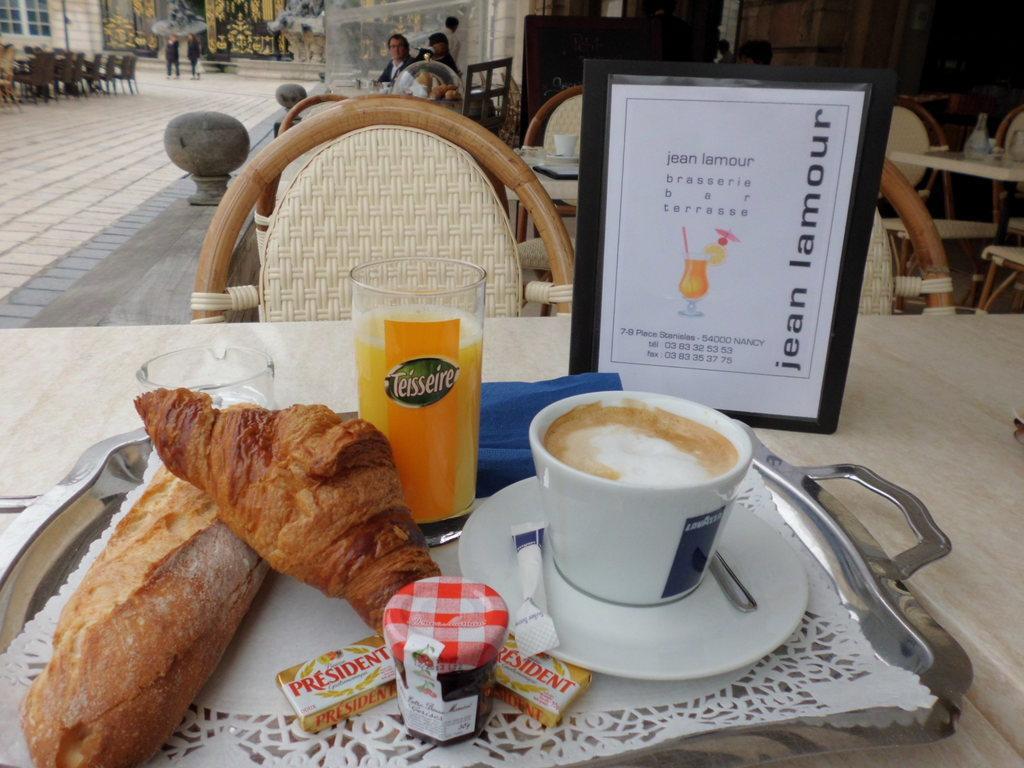Could you give a brief overview of what you see in this image? In the picture I can see few eatables,glass of drink and a coffee on the table and there is a chair in front of it and there are few tables and chairs in the right corner and there are few parsons,chairs and buildings in the left top corner. 